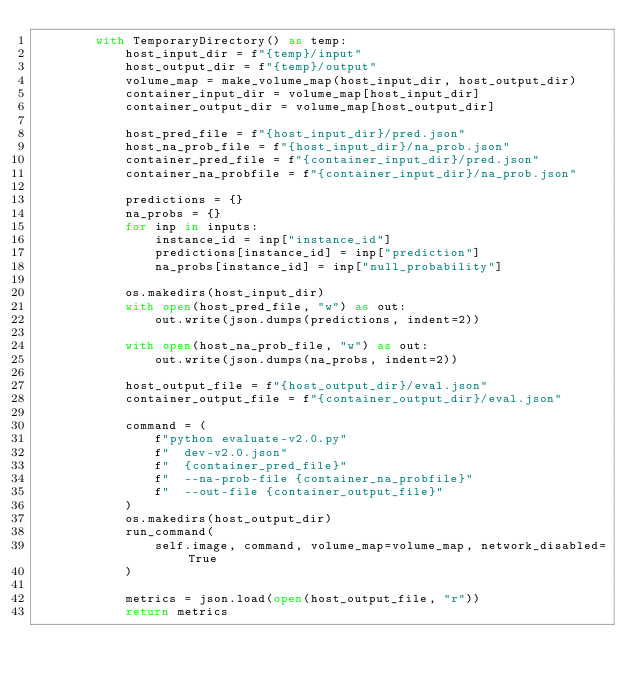<code> <loc_0><loc_0><loc_500><loc_500><_Python_>        with TemporaryDirectory() as temp:
            host_input_dir = f"{temp}/input"
            host_output_dir = f"{temp}/output"
            volume_map = make_volume_map(host_input_dir, host_output_dir)
            container_input_dir = volume_map[host_input_dir]
            container_output_dir = volume_map[host_output_dir]

            host_pred_file = f"{host_input_dir}/pred.json"
            host_na_prob_file = f"{host_input_dir}/na_prob.json"
            container_pred_file = f"{container_input_dir}/pred.json"
            container_na_probfile = f"{container_input_dir}/na_prob.json"

            predictions = {}
            na_probs = {}
            for inp in inputs:
                instance_id = inp["instance_id"]
                predictions[instance_id] = inp["prediction"]
                na_probs[instance_id] = inp["null_probability"]

            os.makedirs(host_input_dir)
            with open(host_pred_file, "w") as out:
                out.write(json.dumps(predictions, indent=2))

            with open(host_na_prob_file, "w") as out:
                out.write(json.dumps(na_probs, indent=2))

            host_output_file = f"{host_output_dir}/eval.json"
            container_output_file = f"{container_output_dir}/eval.json"

            command = (
                f"python evaluate-v2.0.py"
                f"  dev-v2.0.json"
                f"  {container_pred_file}"
                f"  --na-prob-file {container_na_probfile}"
                f"  --out-file {container_output_file}"
            )
            os.makedirs(host_output_dir)
            run_command(
                self.image, command, volume_map=volume_map, network_disabled=True
            )

            metrics = json.load(open(host_output_file, "r"))
            return metrics
</code> 